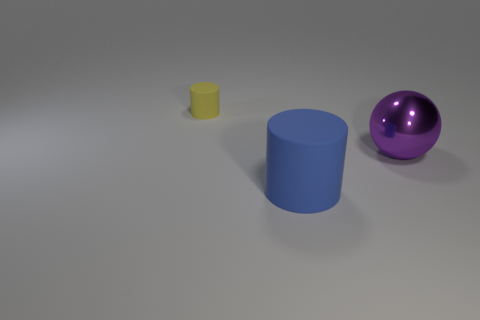Is there any other thing of the same color as the big metal object?
Provide a succinct answer. No. What number of metallic things are either small cubes or big purple things?
Offer a very short reply. 1. How many tiny objects have the same shape as the big metallic object?
Keep it short and to the point. 0. There is a matte object that is on the right side of the tiny yellow cylinder; does it have the same shape as the rubber object to the left of the blue cylinder?
Your answer should be very brief. Yes. What number of objects are either large objects or things left of the purple thing?
Your response must be concise. 3. What number of blue cylinders are the same size as the purple metallic object?
Make the answer very short. 1. How many yellow objects are either tiny things or shiny spheres?
Your response must be concise. 1. There is a matte thing that is behind the thing in front of the ball; what is its shape?
Your answer should be very brief. Cylinder. What shape is the purple thing that is the same size as the blue object?
Keep it short and to the point. Sphere. Are there the same number of large purple objects that are to the right of the large purple object and big purple shiny objects in front of the large blue rubber cylinder?
Make the answer very short. Yes. 